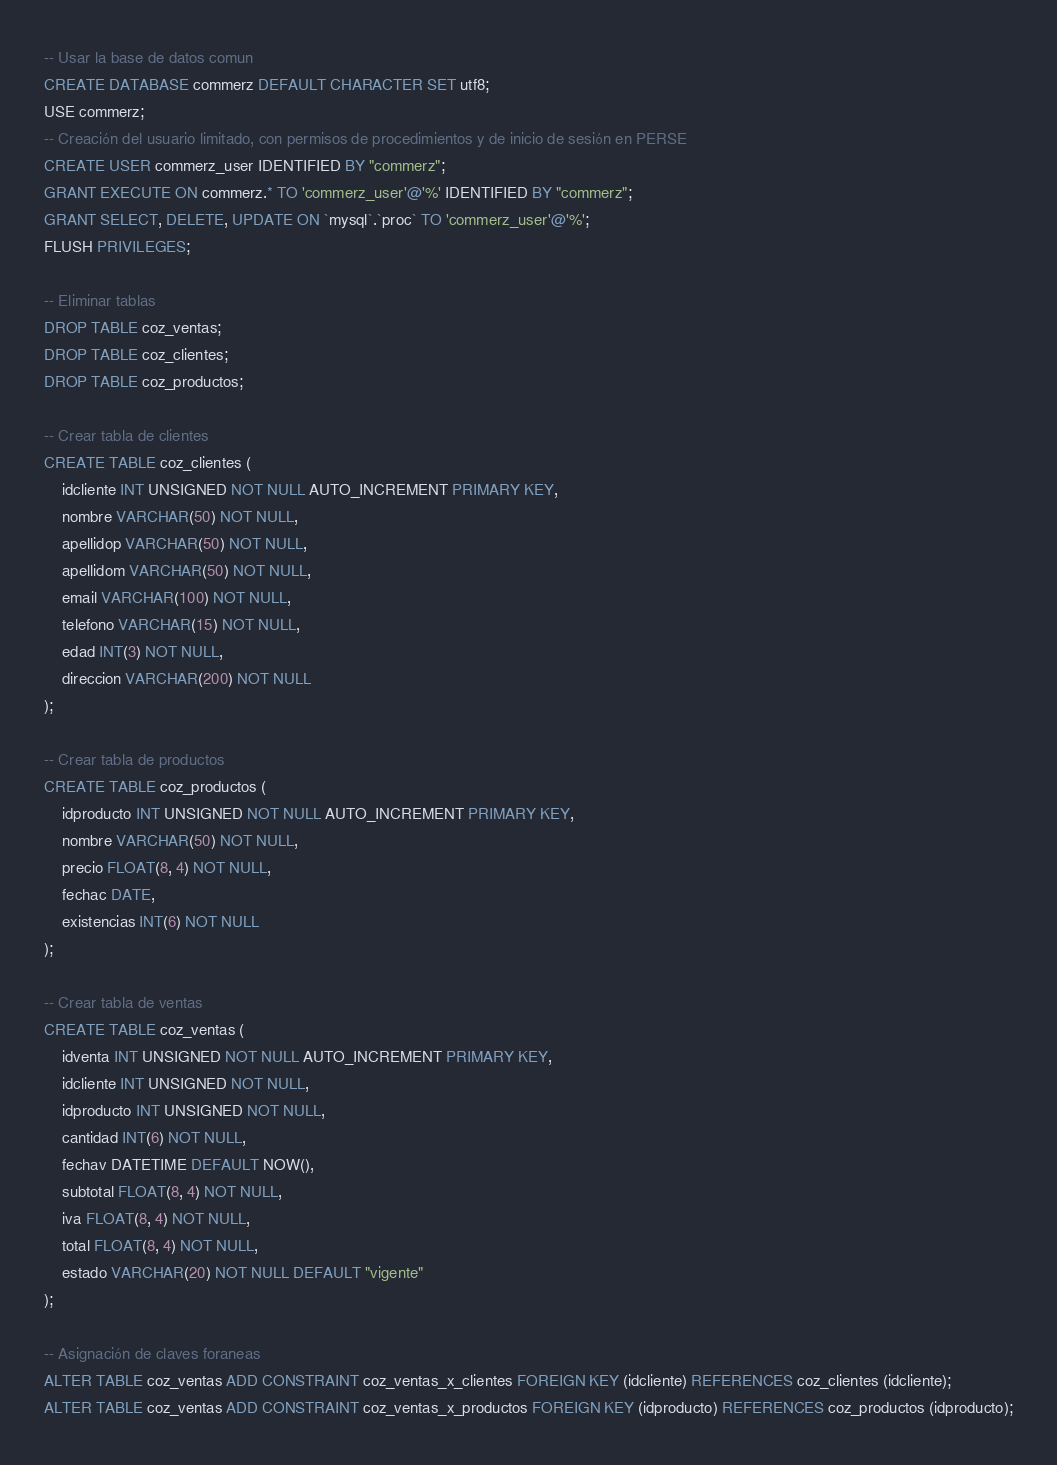Convert code to text. <code><loc_0><loc_0><loc_500><loc_500><_SQL_>-- Usar la base de datos comun
CREATE DATABASE commerz DEFAULT CHARACTER SET utf8;
USE commerz;
-- Creación del usuario limitado, con permisos de procedimientos y de inicio de sesión en PERSE
CREATE USER commerz_user IDENTIFIED BY "commerz";
GRANT EXECUTE ON commerz.* TO 'commerz_user'@'%' IDENTIFIED BY "commerz";
GRANT SELECT, DELETE, UPDATE ON `mysql`.`proc` TO 'commerz_user'@'%';
FLUSH PRIVILEGES;

-- Eliminar tablas
DROP TABLE coz_ventas;
DROP TABLE coz_clientes;
DROP TABLE coz_productos;

-- Crear tabla de clientes
CREATE TABLE coz_clientes (
    idcliente INT UNSIGNED NOT NULL AUTO_INCREMENT PRIMARY KEY,
    nombre VARCHAR(50) NOT NULL,
    apellidop VARCHAR(50) NOT NULL,
    apellidom VARCHAR(50) NOT NULL,
    email VARCHAR(100) NOT NULL,
    telefono VARCHAR(15) NOT NULL,
    edad INT(3) NOT NULL,
    direccion VARCHAR(200) NOT NULL
);

-- Crear tabla de productos
CREATE TABLE coz_productos (
    idproducto INT UNSIGNED NOT NULL AUTO_INCREMENT PRIMARY KEY,
    nombre VARCHAR(50) NOT NULL,
    precio FLOAT(8, 4) NOT NULL,
    fechac DATE,
    existencias INT(6) NOT NULL
);

-- Crear tabla de ventas
CREATE TABLE coz_ventas (
    idventa INT UNSIGNED NOT NULL AUTO_INCREMENT PRIMARY KEY,
    idcliente INT UNSIGNED NOT NULL,
    idproducto INT UNSIGNED NOT NULL,
    cantidad INT(6) NOT NULL,
    fechav DATETIME DEFAULT NOW(),
    subtotal FLOAT(8, 4) NOT NULL,
    iva FLOAT(8, 4) NOT NULL,
    total FLOAT(8, 4) NOT NULL,
    estado VARCHAR(20) NOT NULL DEFAULT "vigente"
);

-- Asignación de claves foraneas
ALTER TABLE coz_ventas ADD CONSTRAINT coz_ventas_x_clientes FOREIGN KEY (idcliente) REFERENCES coz_clientes (idcliente);
ALTER TABLE coz_ventas ADD CONSTRAINT coz_ventas_x_productos FOREIGN KEY (idproducto) REFERENCES coz_productos (idproducto);
</code> 